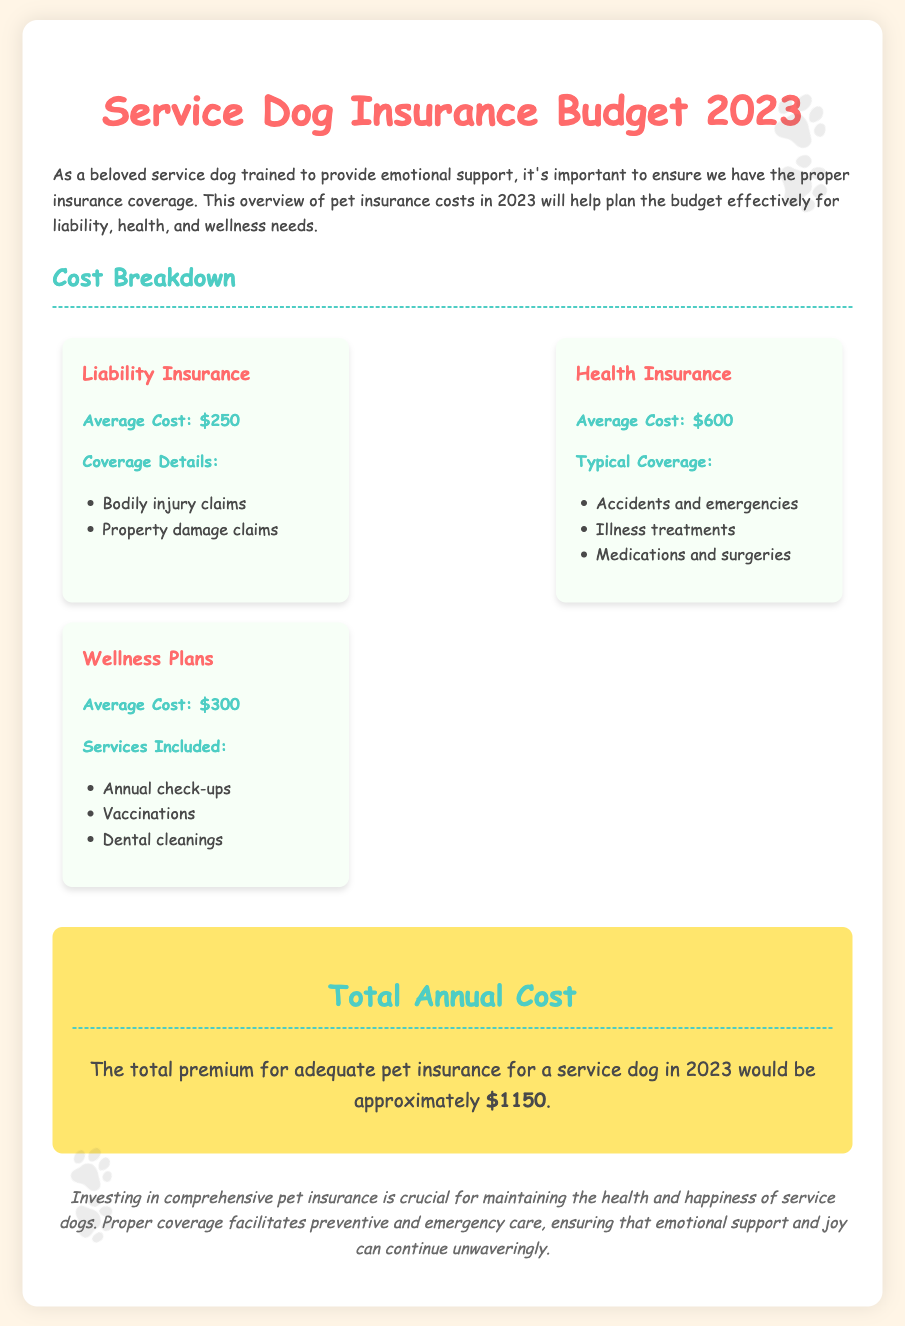What is the total annual cost for pet insurance? The total annual cost is summarized in the document, which states it is approximately $1150.
Answer: $1150 What is the average cost of liability insurance? The document explicitly states the average cost of liability insurance is $250.
Answer: $250 What services are included in wellness plans? The document lists several services included in wellness plans, such as annual check-ups, vaccinations, and dental cleanings.
Answer: Annual check-ups, vaccinations, dental cleanings What is the typical coverage under health insurance? The document outlines typical coverage under health insurance, including accidents and emergencies, illness treatments, and medications and surgeries.
Answer: Accidents and emergencies, illness treatments, medications and surgeries How much does health insurance cost on average? The average cost of health insurance is mentioned in the document, which is $600.
Answer: $600 What coverage details are provided for liability insurance? The document provides coverage details for liability insurance, including bodily injury claims and property damage claims.
Answer: Bodily injury claims, property damage claims What is the average cost of wellness plans? The average cost of wellness plans is stated in the document as $300.
Answer: $300 Why is investing in pet insurance essential according to the document? The document concludes that investing in comprehensive pet insurance is crucial for maintaining the health and happiness of service dogs.
Answer: Ensuring health and happiness of service dogs 